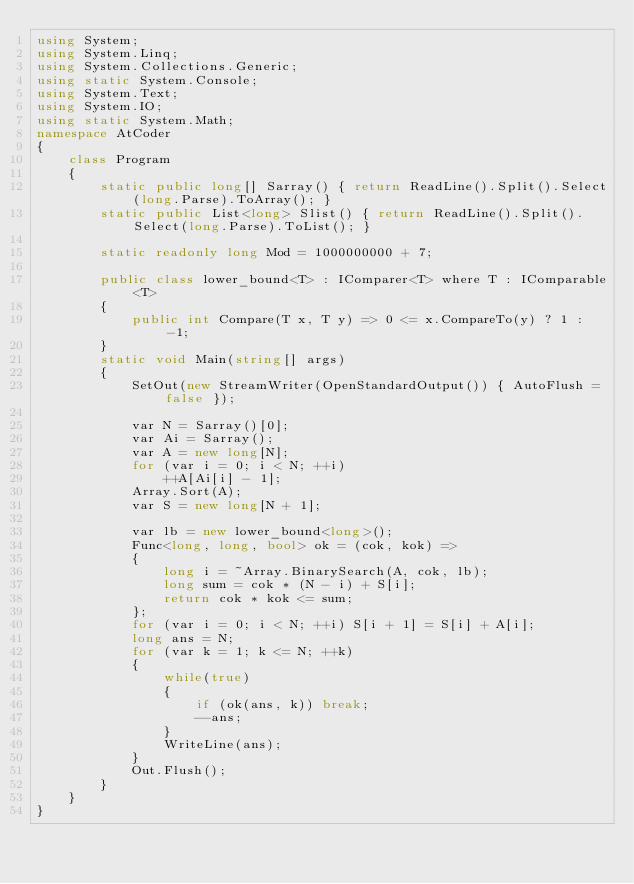<code> <loc_0><loc_0><loc_500><loc_500><_C#_>using System;
using System.Linq;
using System.Collections.Generic;
using static System.Console;
using System.Text;
using System.IO;
using static System.Math;
namespace AtCoder
{
    class Program
    {
        static public long[] Sarray() { return ReadLine().Split().Select(long.Parse).ToArray(); }
        static public List<long> Slist() { return ReadLine().Split().Select(long.Parse).ToList(); }

        static readonly long Mod = 1000000000 + 7;

        public class lower_bound<T> : IComparer<T> where T : IComparable<T>
        {
            public int Compare(T x, T y) => 0 <= x.CompareTo(y) ? 1 : -1;
        }
        static void Main(string[] args)
        {
            SetOut(new StreamWriter(OpenStandardOutput()) { AutoFlush = false });

            var N = Sarray()[0];
            var Ai = Sarray();
            var A = new long[N];
            for (var i = 0; i < N; ++i)
                ++A[Ai[i] - 1];
            Array.Sort(A);
            var S = new long[N + 1];

            var lb = new lower_bound<long>();
            Func<long, long, bool> ok = (cok, kok) =>
            {
                long i = ~Array.BinarySearch(A, cok, lb);
                long sum = cok * (N - i) + S[i];
                return cok * kok <= sum;
            };
            for (var i = 0; i < N; ++i) S[i + 1] = S[i] + A[i];
            long ans = N;
            for (var k = 1; k <= N; ++k)
            {
                while(true)
                {
                    if (ok(ans, k)) break;
                    --ans;
                }
                WriteLine(ans);
            }
            Out.Flush();
        }
    }
}</code> 